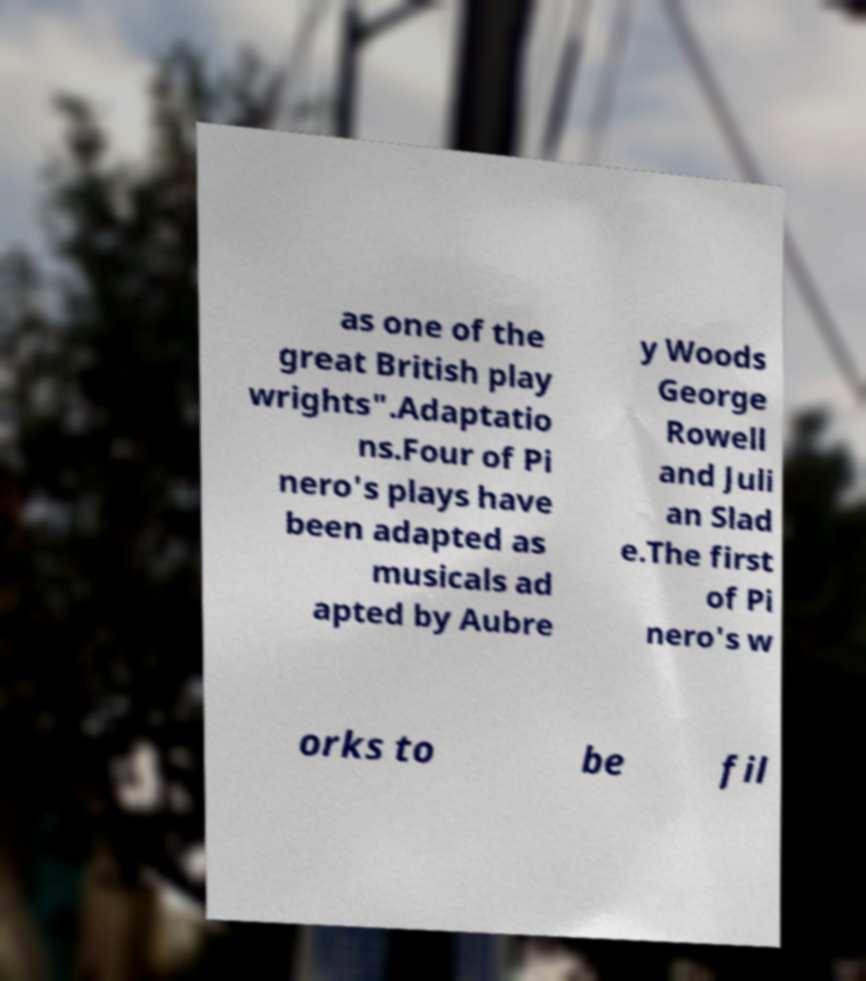For documentation purposes, I need the text within this image transcribed. Could you provide that? as one of the great British play wrights".Adaptatio ns.Four of Pi nero's plays have been adapted as musicals ad apted by Aubre y Woods George Rowell and Juli an Slad e.The first of Pi nero's w orks to be fil 